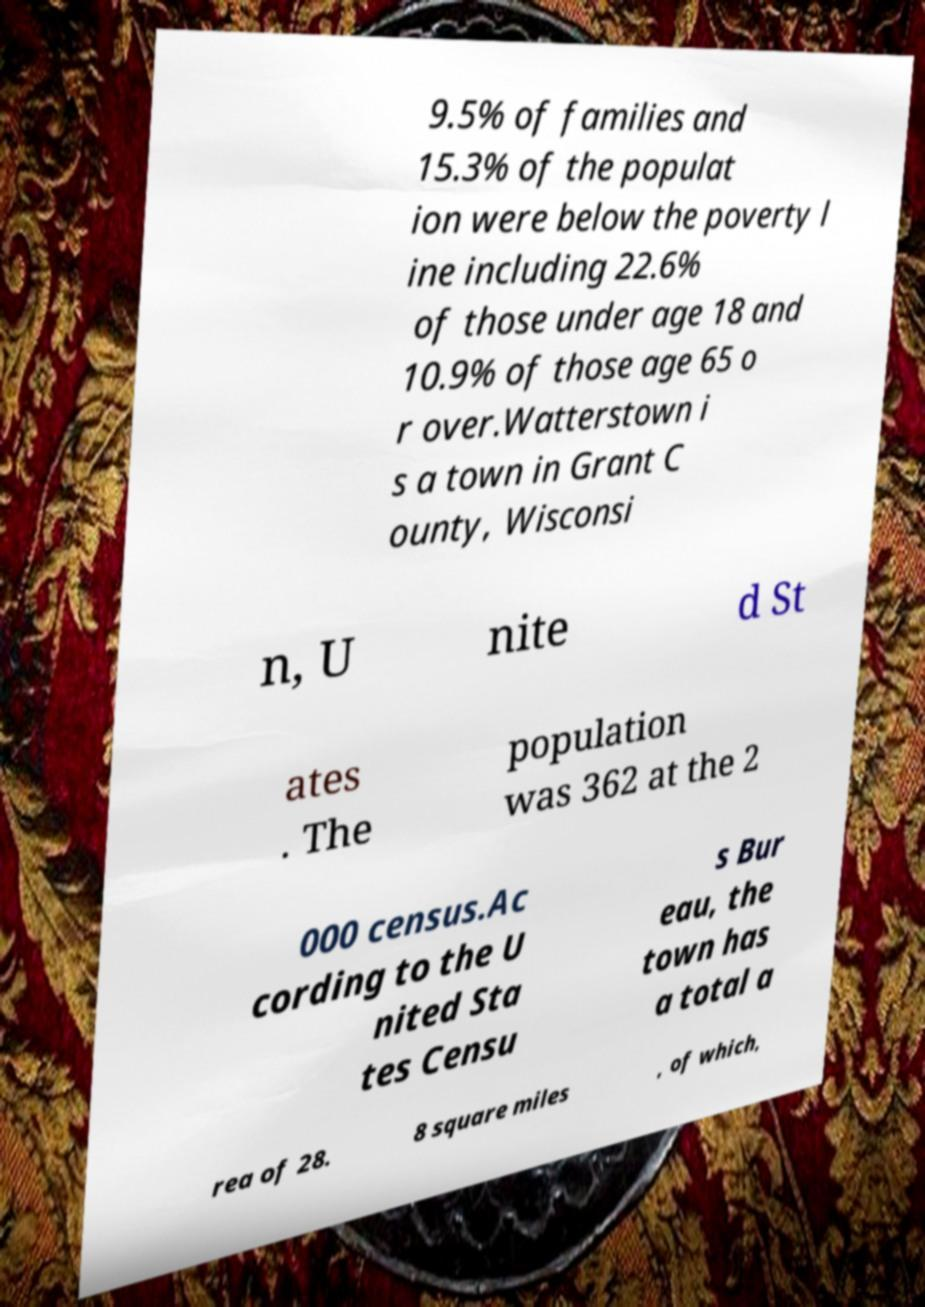Could you extract and type out the text from this image? 9.5% of families and 15.3% of the populat ion were below the poverty l ine including 22.6% of those under age 18 and 10.9% of those age 65 o r over.Watterstown i s a town in Grant C ounty, Wisconsi n, U nite d St ates . The population was 362 at the 2 000 census.Ac cording to the U nited Sta tes Censu s Bur eau, the town has a total a rea of 28. 8 square miles , of which, 